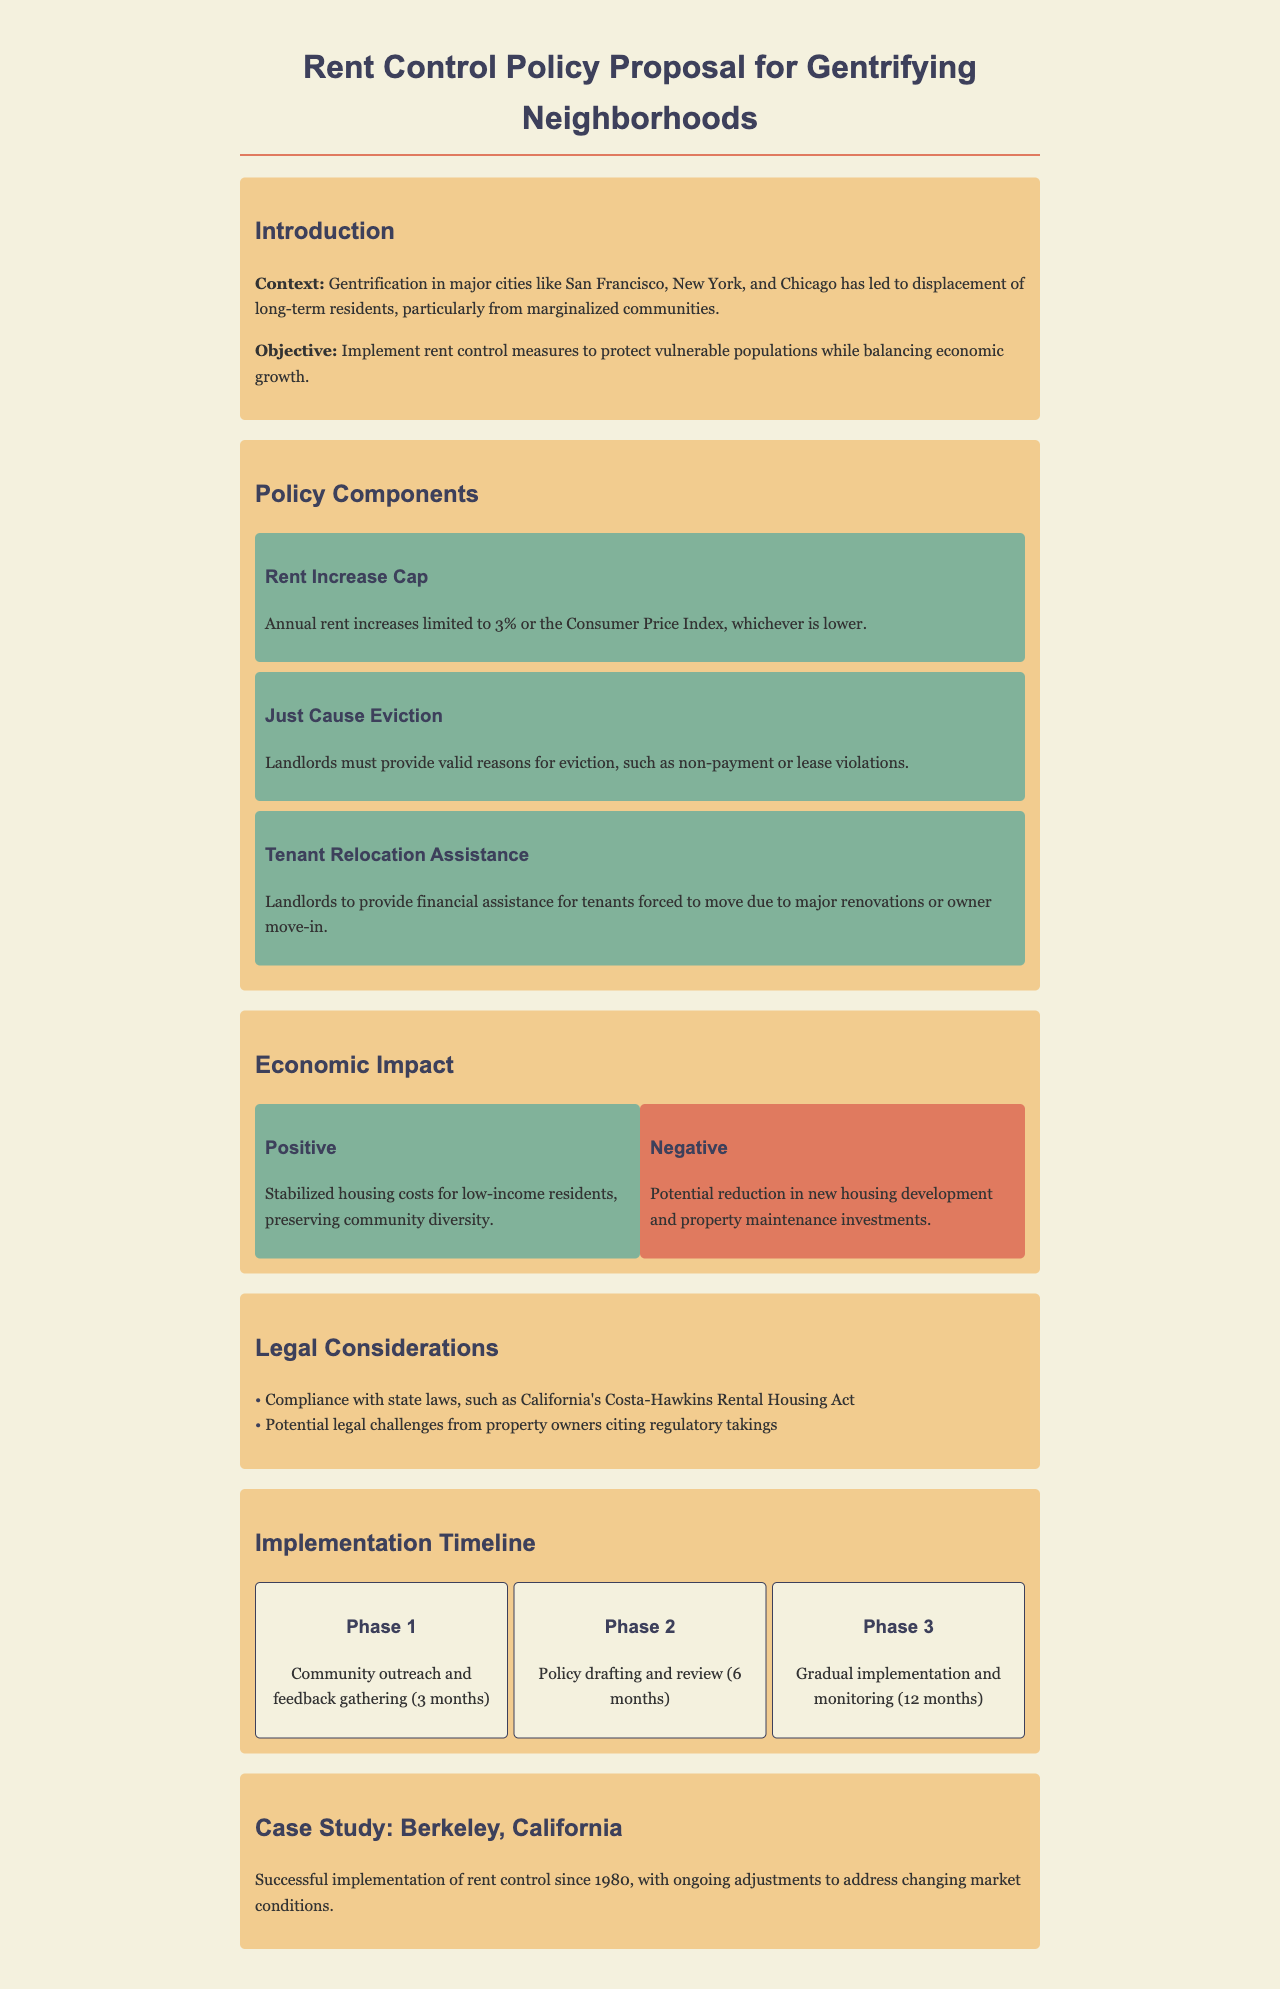What is the annual rent increase cap? The document states that annual rent increases are limited to 3% or the Consumer Price Index, whichever is lower.
Answer: 3% or Consumer Price Index Who must provide valid reasons for eviction? The document specifies that landlords must provide valid reasons for eviction due to non-payment or lease violations.
Answer: Landlords What is the implementation timeline for Phase 1? Phase 1 involves community outreach and feedback gathering, which will take 3 months according to the document.
Answer: 3 months What is a potential negative economic impact of rent control? The document indicates that a potential negative impact is a reduction in new housing development and property maintenance investments.
Answer: Reduction in new housing development What city is used as a case study in the document? The document cites Berkeley, California as a successful case study for rent control.
Answer: Berkeley, California What is the legal act mentioned regarding compliance with state laws? The document refers to California's Costa-Hawkins Rental Housing Act in the context of legal considerations.
Answer: Costa-Hawkins Rental Housing Act What assistance is landlords required to provide for tenants? The document states that landlords must provide financial assistance for tenants forced to move due to major renovations or owner move-in.
Answer: Financial assistance How many phases are there in the implementation timeline? The document outlines three phases in the implementation timeline for the rent control policy.
Answer: Three phases 